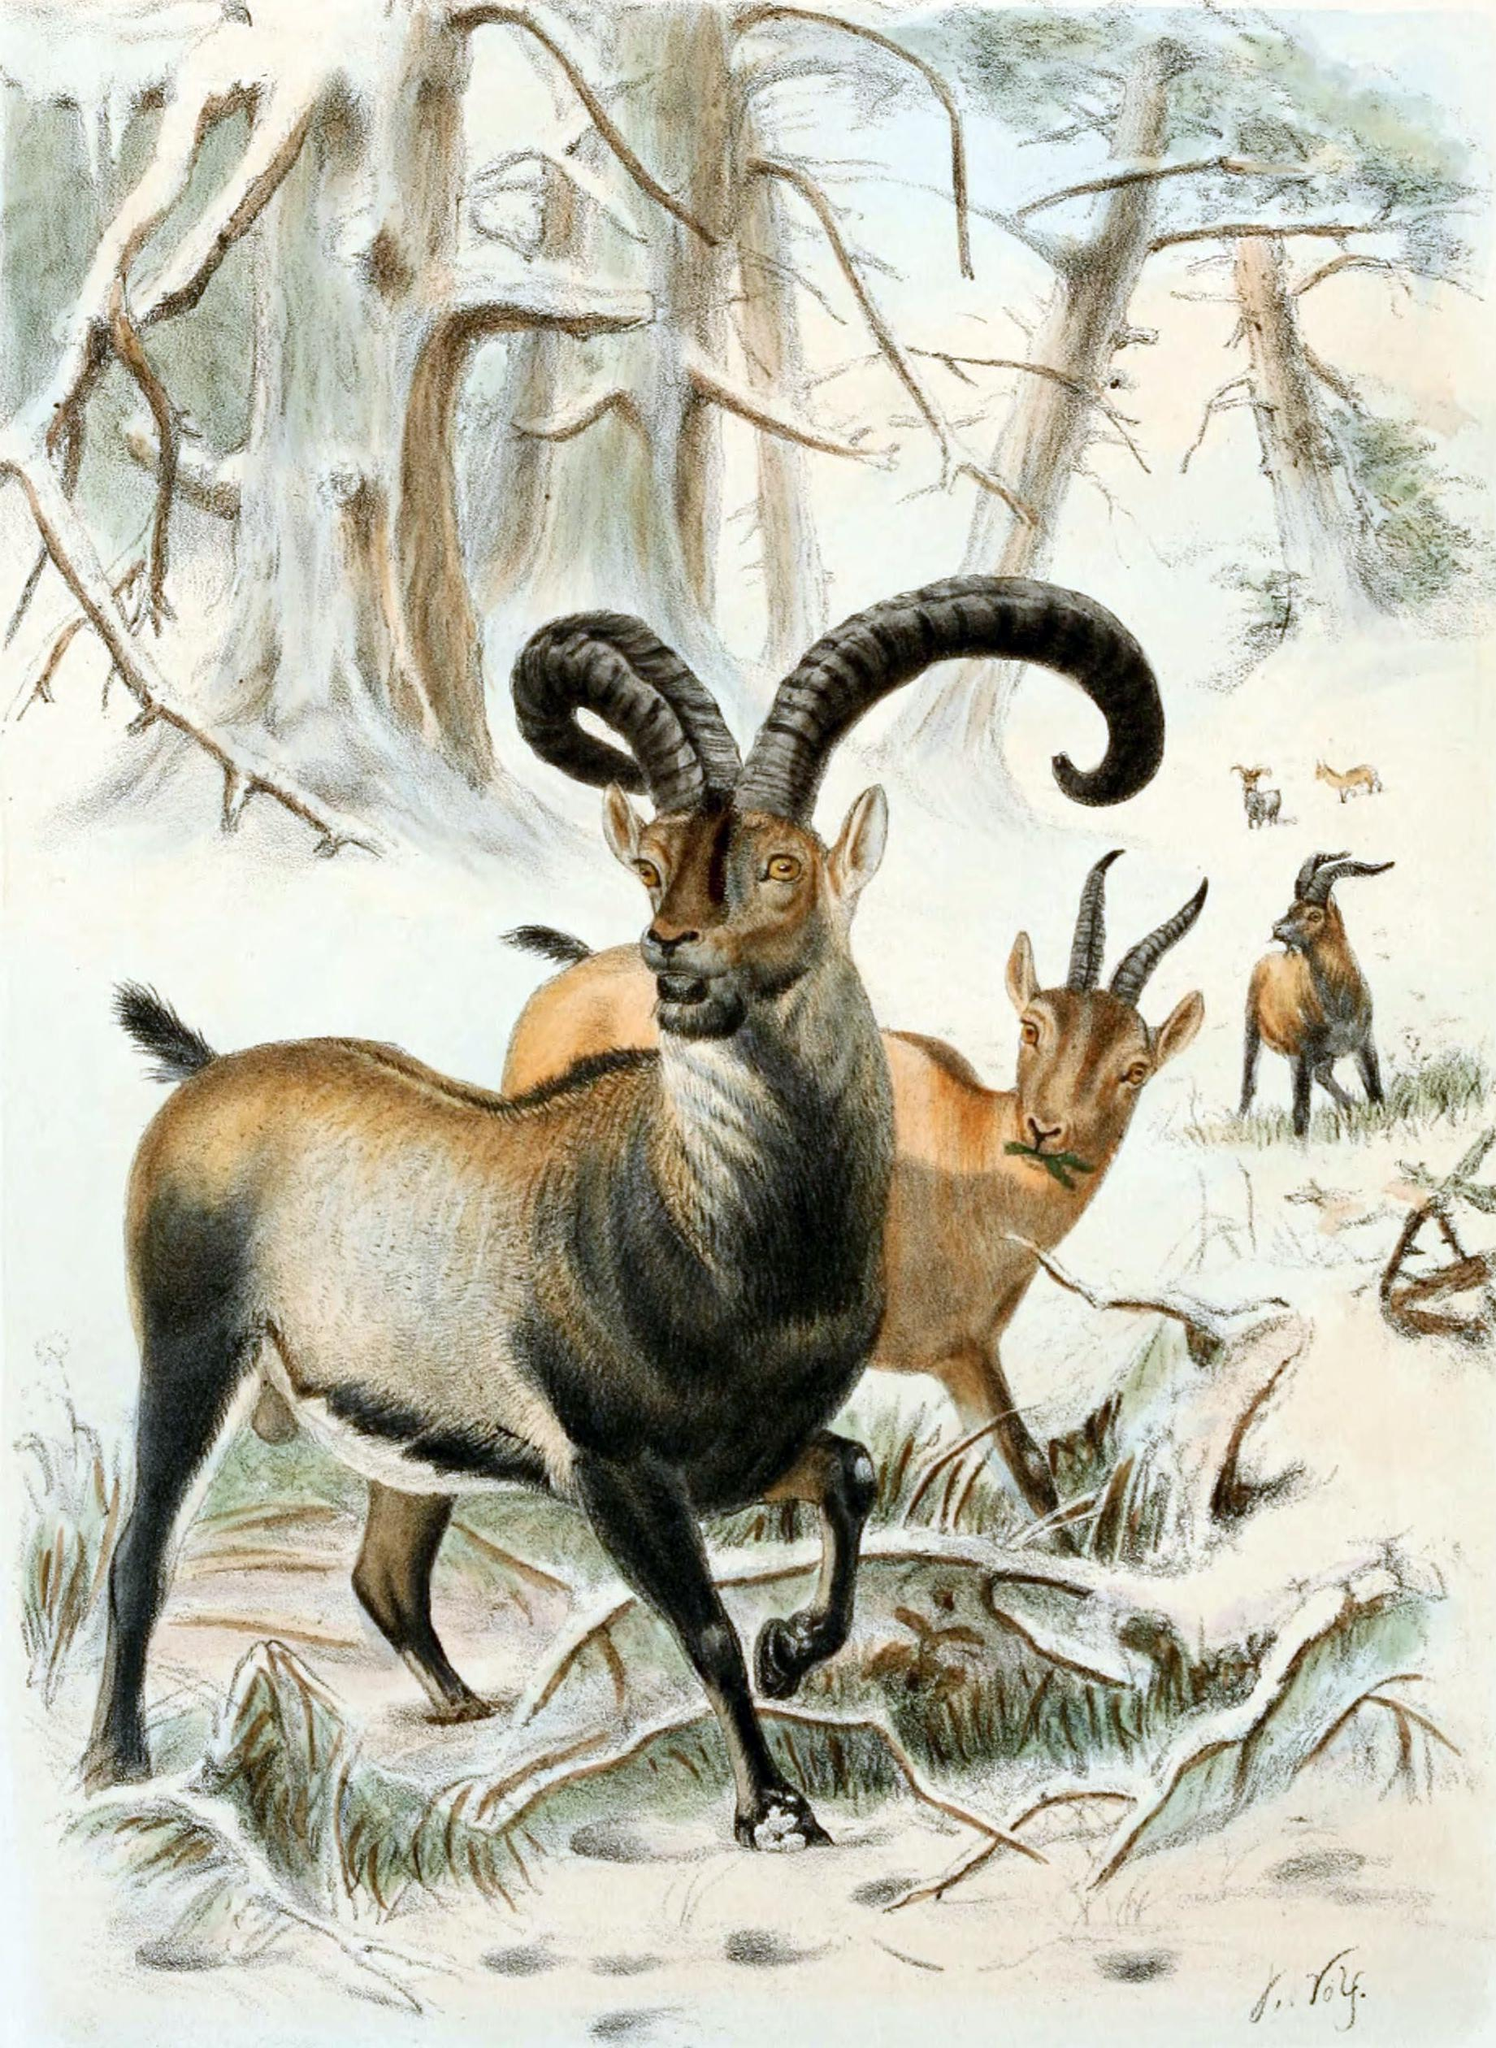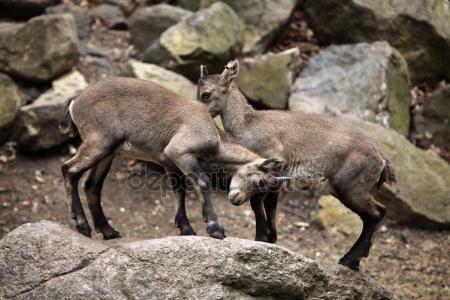The first image is the image on the left, the second image is the image on the right. Assess this claim about the two images: "Two cloven animals are nudging each other with their heads.". Correct or not? Answer yes or no. Yes. 